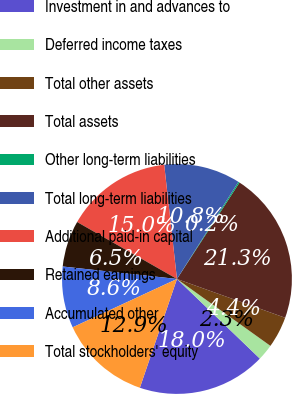Convert chart to OTSL. <chart><loc_0><loc_0><loc_500><loc_500><pie_chart><fcel>Investment in and advances to<fcel>Deferred income taxes<fcel>Total other assets<fcel>Total assets<fcel>Other long-term liabilities<fcel>Total long-term liabilities<fcel>Additional paid-in capital<fcel>Retained earnings<fcel>Accumulated other<fcel>Total stockholders' equity<nl><fcel>18.05%<fcel>2.29%<fcel>4.41%<fcel>21.32%<fcel>0.18%<fcel>10.75%<fcel>14.98%<fcel>6.52%<fcel>8.64%<fcel>12.86%<nl></chart> 